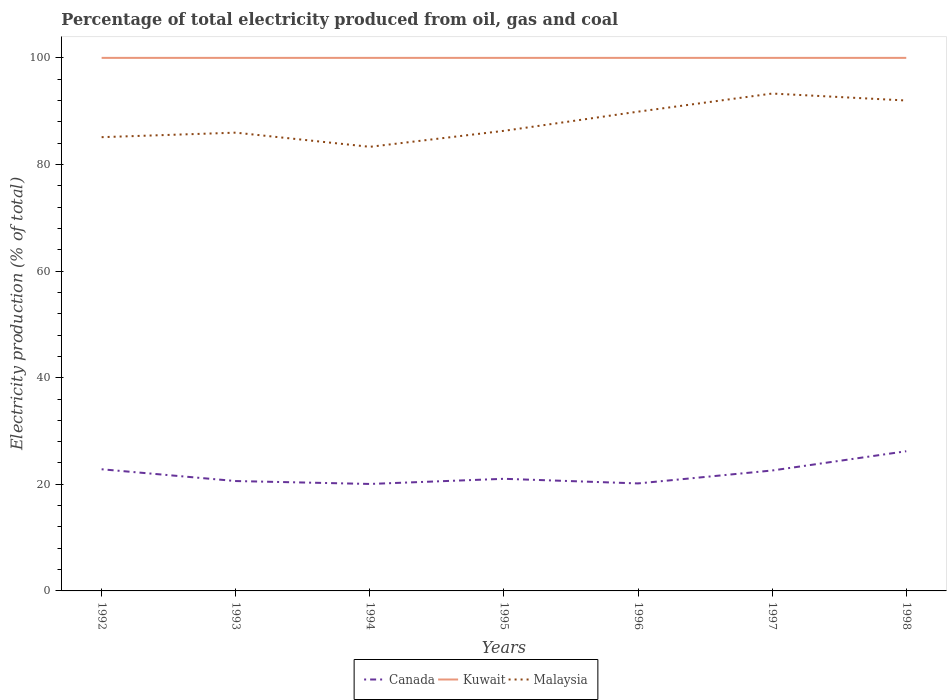How many different coloured lines are there?
Provide a short and direct response. 3. Is the number of lines equal to the number of legend labels?
Your answer should be very brief. Yes. Across all years, what is the maximum electricity production in in Canada?
Make the answer very short. 20.07. What is the total electricity production in in Malaysia in the graph?
Give a very brief answer. -3.6. What is the difference between the highest and the second highest electricity production in in Malaysia?
Offer a terse response. 9.99. What is the difference between the highest and the lowest electricity production in in Malaysia?
Provide a short and direct response. 3. Is the electricity production in in Malaysia strictly greater than the electricity production in in Canada over the years?
Offer a terse response. No. What is the difference between two consecutive major ticks on the Y-axis?
Provide a short and direct response. 20. Does the graph contain grids?
Provide a succinct answer. No. Where does the legend appear in the graph?
Provide a succinct answer. Bottom center. How many legend labels are there?
Your answer should be compact. 3. How are the legend labels stacked?
Your answer should be very brief. Horizontal. What is the title of the graph?
Offer a very short reply. Percentage of total electricity produced from oil, gas and coal. Does "Sri Lanka" appear as one of the legend labels in the graph?
Keep it short and to the point. No. What is the label or title of the Y-axis?
Keep it short and to the point. Electricity production (% of total). What is the Electricity production (% of total) in Canada in 1992?
Your answer should be very brief. 22.82. What is the Electricity production (% of total) in Malaysia in 1992?
Ensure brevity in your answer.  85.13. What is the Electricity production (% of total) of Canada in 1993?
Offer a terse response. 20.61. What is the Electricity production (% of total) in Malaysia in 1993?
Give a very brief answer. 85.97. What is the Electricity production (% of total) of Canada in 1994?
Your response must be concise. 20.07. What is the Electricity production (% of total) of Malaysia in 1994?
Give a very brief answer. 83.31. What is the Electricity production (% of total) of Canada in 1995?
Your answer should be very brief. 21.03. What is the Electricity production (% of total) in Kuwait in 1995?
Your answer should be compact. 100. What is the Electricity production (% of total) in Malaysia in 1995?
Ensure brevity in your answer.  86.31. What is the Electricity production (% of total) in Canada in 1996?
Your answer should be very brief. 20.17. What is the Electricity production (% of total) of Malaysia in 1996?
Provide a succinct answer. 89.91. What is the Electricity production (% of total) of Canada in 1997?
Your answer should be very brief. 22.59. What is the Electricity production (% of total) in Kuwait in 1997?
Offer a very short reply. 100. What is the Electricity production (% of total) in Malaysia in 1997?
Your answer should be very brief. 93.31. What is the Electricity production (% of total) in Canada in 1998?
Ensure brevity in your answer.  26.21. What is the Electricity production (% of total) of Kuwait in 1998?
Give a very brief answer. 100. What is the Electricity production (% of total) of Malaysia in 1998?
Offer a terse response. 92. Across all years, what is the maximum Electricity production (% of total) in Canada?
Provide a short and direct response. 26.21. Across all years, what is the maximum Electricity production (% of total) in Malaysia?
Provide a succinct answer. 93.31. Across all years, what is the minimum Electricity production (% of total) of Canada?
Ensure brevity in your answer.  20.07. Across all years, what is the minimum Electricity production (% of total) of Malaysia?
Provide a succinct answer. 83.31. What is the total Electricity production (% of total) of Canada in the graph?
Offer a terse response. 153.5. What is the total Electricity production (% of total) in Kuwait in the graph?
Give a very brief answer. 700. What is the total Electricity production (% of total) in Malaysia in the graph?
Your answer should be very brief. 615.95. What is the difference between the Electricity production (% of total) of Canada in 1992 and that in 1993?
Provide a short and direct response. 2.21. What is the difference between the Electricity production (% of total) of Malaysia in 1992 and that in 1993?
Give a very brief answer. -0.85. What is the difference between the Electricity production (% of total) in Canada in 1992 and that in 1994?
Your response must be concise. 2.76. What is the difference between the Electricity production (% of total) of Malaysia in 1992 and that in 1994?
Make the answer very short. 1.81. What is the difference between the Electricity production (% of total) in Canada in 1992 and that in 1995?
Your response must be concise. 1.79. What is the difference between the Electricity production (% of total) in Malaysia in 1992 and that in 1995?
Keep it short and to the point. -1.19. What is the difference between the Electricity production (% of total) in Canada in 1992 and that in 1996?
Offer a very short reply. 2.66. What is the difference between the Electricity production (% of total) of Kuwait in 1992 and that in 1996?
Your response must be concise. 0. What is the difference between the Electricity production (% of total) in Malaysia in 1992 and that in 1996?
Your answer should be compact. -4.79. What is the difference between the Electricity production (% of total) of Canada in 1992 and that in 1997?
Offer a very short reply. 0.23. What is the difference between the Electricity production (% of total) of Malaysia in 1992 and that in 1997?
Make the answer very short. -8.18. What is the difference between the Electricity production (% of total) of Canada in 1992 and that in 1998?
Your response must be concise. -3.38. What is the difference between the Electricity production (% of total) in Malaysia in 1992 and that in 1998?
Offer a very short reply. -6.88. What is the difference between the Electricity production (% of total) of Canada in 1993 and that in 1994?
Keep it short and to the point. 0.55. What is the difference between the Electricity production (% of total) of Malaysia in 1993 and that in 1994?
Your answer should be very brief. 2.66. What is the difference between the Electricity production (% of total) in Canada in 1993 and that in 1995?
Your answer should be very brief. -0.42. What is the difference between the Electricity production (% of total) of Kuwait in 1993 and that in 1995?
Give a very brief answer. 0. What is the difference between the Electricity production (% of total) of Malaysia in 1993 and that in 1995?
Provide a succinct answer. -0.34. What is the difference between the Electricity production (% of total) of Canada in 1993 and that in 1996?
Your response must be concise. 0.45. What is the difference between the Electricity production (% of total) in Malaysia in 1993 and that in 1996?
Ensure brevity in your answer.  -3.94. What is the difference between the Electricity production (% of total) in Canada in 1993 and that in 1997?
Keep it short and to the point. -1.98. What is the difference between the Electricity production (% of total) in Kuwait in 1993 and that in 1997?
Provide a succinct answer. 0. What is the difference between the Electricity production (% of total) in Malaysia in 1993 and that in 1997?
Offer a very short reply. -7.34. What is the difference between the Electricity production (% of total) in Canada in 1993 and that in 1998?
Offer a terse response. -5.59. What is the difference between the Electricity production (% of total) of Malaysia in 1993 and that in 1998?
Ensure brevity in your answer.  -6.03. What is the difference between the Electricity production (% of total) in Canada in 1994 and that in 1995?
Your response must be concise. -0.97. What is the difference between the Electricity production (% of total) of Malaysia in 1994 and that in 1995?
Provide a succinct answer. -3. What is the difference between the Electricity production (% of total) of Canada in 1994 and that in 1996?
Give a very brief answer. -0.1. What is the difference between the Electricity production (% of total) of Kuwait in 1994 and that in 1996?
Your answer should be very brief. 0. What is the difference between the Electricity production (% of total) in Malaysia in 1994 and that in 1996?
Offer a terse response. -6.6. What is the difference between the Electricity production (% of total) of Canada in 1994 and that in 1997?
Give a very brief answer. -2.53. What is the difference between the Electricity production (% of total) in Malaysia in 1994 and that in 1997?
Give a very brief answer. -9.99. What is the difference between the Electricity production (% of total) in Canada in 1994 and that in 1998?
Keep it short and to the point. -6.14. What is the difference between the Electricity production (% of total) of Kuwait in 1994 and that in 1998?
Give a very brief answer. 0. What is the difference between the Electricity production (% of total) of Malaysia in 1994 and that in 1998?
Provide a short and direct response. -8.69. What is the difference between the Electricity production (% of total) of Canada in 1995 and that in 1996?
Give a very brief answer. 0.87. What is the difference between the Electricity production (% of total) of Kuwait in 1995 and that in 1996?
Provide a short and direct response. 0. What is the difference between the Electricity production (% of total) of Malaysia in 1995 and that in 1996?
Give a very brief answer. -3.6. What is the difference between the Electricity production (% of total) in Canada in 1995 and that in 1997?
Make the answer very short. -1.56. What is the difference between the Electricity production (% of total) in Malaysia in 1995 and that in 1997?
Give a very brief answer. -7. What is the difference between the Electricity production (% of total) of Canada in 1995 and that in 1998?
Offer a very short reply. -5.17. What is the difference between the Electricity production (% of total) of Malaysia in 1995 and that in 1998?
Make the answer very short. -5.69. What is the difference between the Electricity production (% of total) in Canada in 1996 and that in 1997?
Offer a very short reply. -2.43. What is the difference between the Electricity production (% of total) in Kuwait in 1996 and that in 1997?
Offer a very short reply. 0. What is the difference between the Electricity production (% of total) in Malaysia in 1996 and that in 1997?
Give a very brief answer. -3.4. What is the difference between the Electricity production (% of total) in Canada in 1996 and that in 1998?
Your answer should be very brief. -6.04. What is the difference between the Electricity production (% of total) in Malaysia in 1996 and that in 1998?
Your answer should be very brief. -2.09. What is the difference between the Electricity production (% of total) of Canada in 1997 and that in 1998?
Your answer should be compact. -3.61. What is the difference between the Electricity production (% of total) of Malaysia in 1997 and that in 1998?
Provide a succinct answer. 1.31. What is the difference between the Electricity production (% of total) of Canada in 1992 and the Electricity production (% of total) of Kuwait in 1993?
Offer a very short reply. -77.18. What is the difference between the Electricity production (% of total) in Canada in 1992 and the Electricity production (% of total) in Malaysia in 1993?
Ensure brevity in your answer.  -63.15. What is the difference between the Electricity production (% of total) of Kuwait in 1992 and the Electricity production (% of total) of Malaysia in 1993?
Your answer should be very brief. 14.03. What is the difference between the Electricity production (% of total) in Canada in 1992 and the Electricity production (% of total) in Kuwait in 1994?
Your answer should be very brief. -77.18. What is the difference between the Electricity production (% of total) of Canada in 1992 and the Electricity production (% of total) of Malaysia in 1994?
Your answer should be compact. -60.49. What is the difference between the Electricity production (% of total) of Kuwait in 1992 and the Electricity production (% of total) of Malaysia in 1994?
Your answer should be compact. 16.69. What is the difference between the Electricity production (% of total) in Canada in 1992 and the Electricity production (% of total) in Kuwait in 1995?
Provide a short and direct response. -77.18. What is the difference between the Electricity production (% of total) in Canada in 1992 and the Electricity production (% of total) in Malaysia in 1995?
Provide a short and direct response. -63.49. What is the difference between the Electricity production (% of total) in Kuwait in 1992 and the Electricity production (% of total) in Malaysia in 1995?
Your answer should be compact. 13.69. What is the difference between the Electricity production (% of total) of Canada in 1992 and the Electricity production (% of total) of Kuwait in 1996?
Your answer should be compact. -77.18. What is the difference between the Electricity production (% of total) of Canada in 1992 and the Electricity production (% of total) of Malaysia in 1996?
Your answer should be very brief. -67.09. What is the difference between the Electricity production (% of total) of Kuwait in 1992 and the Electricity production (% of total) of Malaysia in 1996?
Offer a very short reply. 10.09. What is the difference between the Electricity production (% of total) of Canada in 1992 and the Electricity production (% of total) of Kuwait in 1997?
Your response must be concise. -77.18. What is the difference between the Electricity production (% of total) in Canada in 1992 and the Electricity production (% of total) in Malaysia in 1997?
Your response must be concise. -70.49. What is the difference between the Electricity production (% of total) in Kuwait in 1992 and the Electricity production (% of total) in Malaysia in 1997?
Keep it short and to the point. 6.69. What is the difference between the Electricity production (% of total) of Canada in 1992 and the Electricity production (% of total) of Kuwait in 1998?
Ensure brevity in your answer.  -77.18. What is the difference between the Electricity production (% of total) of Canada in 1992 and the Electricity production (% of total) of Malaysia in 1998?
Make the answer very short. -69.18. What is the difference between the Electricity production (% of total) in Kuwait in 1992 and the Electricity production (% of total) in Malaysia in 1998?
Keep it short and to the point. 8. What is the difference between the Electricity production (% of total) in Canada in 1993 and the Electricity production (% of total) in Kuwait in 1994?
Offer a terse response. -79.39. What is the difference between the Electricity production (% of total) in Canada in 1993 and the Electricity production (% of total) in Malaysia in 1994?
Provide a short and direct response. -62.7. What is the difference between the Electricity production (% of total) in Kuwait in 1993 and the Electricity production (% of total) in Malaysia in 1994?
Provide a succinct answer. 16.69. What is the difference between the Electricity production (% of total) in Canada in 1993 and the Electricity production (% of total) in Kuwait in 1995?
Ensure brevity in your answer.  -79.39. What is the difference between the Electricity production (% of total) of Canada in 1993 and the Electricity production (% of total) of Malaysia in 1995?
Ensure brevity in your answer.  -65.7. What is the difference between the Electricity production (% of total) of Kuwait in 1993 and the Electricity production (% of total) of Malaysia in 1995?
Provide a succinct answer. 13.69. What is the difference between the Electricity production (% of total) of Canada in 1993 and the Electricity production (% of total) of Kuwait in 1996?
Make the answer very short. -79.39. What is the difference between the Electricity production (% of total) in Canada in 1993 and the Electricity production (% of total) in Malaysia in 1996?
Ensure brevity in your answer.  -69.3. What is the difference between the Electricity production (% of total) of Kuwait in 1993 and the Electricity production (% of total) of Malaysia in 1996?
Your response must be concise. 10.09. What is the difference between the Electricity production (% of total) of Canada in 1993 and the Electricity production (% of total) of Kuwait in 1997?
Ensure brevity in your answer.  -79.39. What is the difference between the Electricity production (% of total) in Canada in 1993 and the Electricity production (% of total) in Malaysia in 1997?
Your answer should be very brief. -72.69. What is the difference between the Electricity production (% of total) in Kuwait in 1993 and the Electricity production (% of total) in Malaysia in 1997?
Offer a terse response. 6.69. What is the difference between the Electricity production (% of total) in Canada in 1993 and the Electricity production (% of total) in Kuwait in 1998?
Make the answer very short. -79.39. What is the difference between the Electricity production (% of total) in Canada in 1993 and the Electricity production (% of total) in Malaysia in 1998?
Make the answer very short. -71.39. What is the difference between the Electricity production (% of total) of Kuwait in 1993 and the Electricity production (% of total) of Malaysia in 1998?
Give a very brief answer. 8. What is the difference between the Electricity production (% of total) in Canada in 1994 and the Electricity production (% of total) in Kuwait in 1995?
Ensure brevity in your answer.  -79.93. What is the difference between the Electricity production (% of total) in Canada in 1994 and the Electricity production (% of total) in Malaysia in 1995?
Offer a terse response. -66.25. What is the difference between the Electricity production (% of total) of Kuwait in 1994 and the Electricity production (% of total) of Malaysia in 1995?
Provide a succinct answer. 13.69. What is the difference between the Electricity production (% of total) of Canada in 1994 and the Electricity production (% of total) of Kuwait in 1996?
Offer a terse response. -79.93. What is the difference between the Electricity production (% of total) in Canada in 1994 and the Electricity production (% of total) in Malaysia in 1996?
Your answer should be compact. -69.85. What is the difference between the Electricity production (% of total) of Kuwait in 1994 and the Electricity production (% of total) of Malaysia in 1996?
Ensure brevity in your answer.  10.09. What is the difference between the Electricity production (% of total) of Canada in 1994 and the Electricity production (% of total) of Kuwait in 1997?
Offer a terse response. -79.93. What is the difference between the Electricity production (% of total) in Canada in 1994 and the Electricity production (% of total) in Malaysia in 1997?
Provide a short and direct response. -73.24. What is the difference between the Electricity production (% of total) of Kuwait in 1994 and the Electricity production (% of total) of Malaysia in 1997?
Give a very brief answer. 6.69. What is the difference between the Electricity production (% of total) of Canada in 1994 and the Electricity production (% of total) of Kuwait in 1998?
Offer a terse response. -79.93. What is the difference between the Electricity production (% of total) in Canada in 1994 and the Electricity production (% of total) in Malaysia in 1998?
Provide a succinct answer. -71.94. What is the difference between the Electricity production (% of total) in Kuwait in 1994 and the Electricity production (% of total) in Malaysia in 1998?
Your response must be concise. 8. What is the difference between the Electricity production (% of total) of Canada in 1995 and the Electricity production (% of total) of Kuwait in 1996?
Your answer should be compact. -78.97. What is the difference between the Electricity production (% of total) in Canada in 1995 and the Electricity production (% of total) in Malaysia in 1996?
Ensure brevity in your answer.  -68.88. What is the difference between the Electricity production (% of total) in Kuwait in 1995 and the Electricity production (% of total) in Malaysia in 1996?
Your answer should be very brief. 10.09. What is the difference between the Electricity production (% of total) of Canada in 1995 and the Electricity production (% of total) of Kuwait in 1997?
Offer a very short reply. -78.97. What is the difference between the Electricity production (% of total) in Canada in 1995 and the Electricity production (% of total) in Malaysia in 1997?
Keep it short and to the point. -72.28. What is the difference between the Electricity production (% of total) of Kuwait in 1995 and the Electricity production (% of total) of Malaysia in 1997?
Your response must be concise. 6.69. What is the difference between the Electricity production (% of total) in Canada in 1995 and the Electricity production (% of total) in Kuwait in 1998?
Your answer should be compact. -78.97. What is the difference between the Electricity production (% of total) in Canada in 1995 and the Electricity production (% of total) in Malaysia in 1998?
Make the answer very short. -70.97. What is the difference between the Electricity production (% of total) of Kuwait in 1995 and the Electricity production (% of total) of Malaysia in 1998?
Offer a very short reply. 8. What is the difference between the Electricity production (% of total) of Canada in 1996 and the Electricity production (% of total) of Kuwait in 1997?
Your answer should be very brief. -79.83. What is the difference between the Electricity production (% of total) of Canada in 1996 and the Electricity production (% of total) of Malaysia in 1997?
Your response must be concise. -73.14. What is the difference between the Electricity production (% of total) in Kuwait in 1996 and the Electricity production (% of total) in Malaysia in 1997?
Your answer should be very brief. 6.69. What is the difference between the Electricity production (% of total) in Canada in 1996 and the Electricity production (% of total) in Kuwait in 1998?
Your answer should be very brief. -79.83. What is the difference between the Electricity production (% of total) of Canada in 1996 and the Electricity production (% of total) of Malaysia in 1998?
Offer a terse response. -71.84. What is the difference between the Electricity production (% of total) of Kuwait in 1996 and the Electricity production (% of total) of Malaysia in 1998?
Offer a very short reply. 8. What is the difference between the Electricity production (% of total) of Canada in 1997 and the Electricity production (% of total) of Kuwait in 1998?
Keep it short and to the point. -77.41. What is the difference between the Electricity production (% of total) of Canada in 1997 and the Electricity production (% of total) of Malaysia in 1998?
Offer a terse response. -69.41. What is the difference between the Electricity production (% of total) of Kuwait in 1997 and the Electricity production (% of total) of Malaysia in 1998?
Your answer should be very brief. 8. What is the average Electricity production (% of total) of Canada per year?
Offer a terse response. 21.93. What is the average Electricity production (% of total) of Malaysia per year?
Your response must be concise. 87.99. In the year 1992, what is the difference between the Electricity production (% of total) in Canada and Electricity production (% of total) in Kuwait?
Your answer should be compact. -77.18. In the year 1992, what is the difference between the Electricity production (% of total) in Canada and Electricity production (% of total) in Malaysia?
Offer a terse response. -62.3. In the year 1992, what is the difference between the Electricity production (% of total) in Kuwait and Electricity production (% of total) in Malaysia?
Give a very brief answer. 14.87. In the year 1993, what is the difference between the Electricity production (% of total) in Canada and Electricity production (% of total) in Kuwait?
Ensure brevity in your answer.  -79.39. In the year 1993, what is the difference between the Electricity production (% of total) in Canada and Electricity production (% of total) in Malaysia?
Your answer should be very brief. -65.36. In the year 1993, what is the difference between the Electricity production (% of total) of Kuwait and Electricity production (% of total) of Malaysia?
Offer a very short reply. 14.03. In the year 1994, what is the difference between the Electricity production (% of total) of Canada and Electricity production (% of total) of Kuwait?
Give a very brief answer. -79.93. In the year 1994, what is the difference between the Electricity production (% of total) in Canada and Electricity production (% of total) in Malaysia?
Provide a succinct answer. -63.25. In the year 1994, what is the difference between the Electricity production (% of total) in Kuwait and Electricity production (% of total) in Malaysia?
Offer a terse response. 16.69. In the year 1995, what is the difference between the Electricity production (% of total) of Canada and Electricity production (% of total) of Kuwait?
Your answer should be very brief. -78.97. In the year 1995, what is the difference between the Electricity production (% of total) in Canada and Electricity production (% of total) in Malaysia?
Ensure brevity in your answer.  -65.28. In the year 1995, what is the difference between the Electricity production (% of total) in Kuwait and Electricity production (% of total) in Malaysia?
Give a very brief answer. 13.69. In the year 1996, what is the difference between the Electricity production (% of total) of Canada and Electricity production (% of total) of Kuwait?
Make the answer very short. -79.83. In the year 1996, what is the difference between the Electricity production (% of total) of Canada and Electricity production (% of total) of Malaysia?
Provide a succinct answer. -69.74. In the year 1996, what is the difference between the Electricity production (% of total) in Kuwait and Electricity production (% of total) in Malaysia?
Keep it short and to the point. 10.09. In the year 1997, what is the difference between the Electricity production (% of total) of Canada and Electricity production (% of total) of Kuwait?
Provide a short and direct response. -77.41. In the year 1997, what is the difference between the Electricity production (% of total) in Canada and Electricity production (% of total) in Malaysia?
Your answer should be compact. -70.72. In the year 1997, what is the difference between the Electricity production (% of total) of Kuwait and Electricity production (% of total) of Malaysia?
Ensure brevity in your answer.  6.69. In the year 1998, what is the difference between the Electricity production (% of total) in Canada and Electricity production (% of total) in Kuwait?
Provide a succinct answer. -73.79. In the year 1998, what is the difference between the Electricity production (% of total) of Canada and Electricity production (% of total) of Malaysia?
Make the answer very short. -65.8. In the year 1998, what is the difference between the Electricity production (% of total) of Kuwait and Electricity production (% of total) of Malaysia?
Your response must be concise. 8. What is the ratio of the Electricity production (% of total) of Canada in 1992 to that in 1993?
Keep it short and to the point. 1.11. What is the ratio of the Electricity production (% of total) in Canada in 1992 to that in 1994?
Offer a terse response. 1.14. What is the ratio of the Electricity production (% of total) in Kuwait in 1992 to that in 1994?
Provide a succinct answer. 1. What is the ratio of the Electricity production (% of total) of Malaysia in 1992 to that in 1994?
Your answer should be very brief. 1.02. What is the ratio of the Electricity production (% of total) in Canada in 1992 to that in 1995?
Provide a short and direct response. 1.09. What is the ratio of the Electricity production (% of total) in Malaysia in 1992 to that in 1995?
Keep it short and to the point. 0.99. What is the ratio of the Electricity production (% of total) of Canada in 1992 to that in 1996?
Give a very brief answer. 1.13. What is the ratio of the Electricity production (% of total) of Kuwait in 1992 to that in 1996?
Make the answer very short. 1. What is the ratio of the Electricity production (% of total) in Malaysia in 1992 to that in 1996?
Ensure brevity in your answer.  0.95. What is the ratio of the Electricity production (% of total) of Canada in 1992 to that in 1997?
Offer a terse response. 1.01. What is the ratio of the Electricity production (% of total) of Kuwait in 1992 to that in 1997?
Provide a short and direct response. 1. What is the ratio of the Electricity production (% of total) of Malaysia in 1992 to that in 1997?
Keep it short and to the point. 0.91. What is the ratio of the Electricity production (% of total) in Canada in 1992 to that in 1998?
Keep it short and to the point. 0.87. What is the ratio of the Electricity production (% of total) of Kuwait in 1992 to that in 1998?
Give a very brief answer. 1. What is the ratio of the Electricity production (% of total) in Malaysia in 1992 to that in 1998?
Provide a short and direct response. 0.93. What is the ratio of the Electricity production (% of total) in Canada in 1993 to that in 1994?
Ensure brevity in your answer.  1.03. What is the ratio of the Electricity production (% of total) in Kuwait in 1993 to that in 1994?
Provide a succinct answer. 1. What is the ratio of the Electricity production (% of total) in Malaysia in 1993 to that in 1994?
Your answer should be very brief. 1.03. What is the ratio of the Electricity production (% of total) in Canada in 1993 to that in 1995?
Make the answer very short. 0.98. What is the ratio of the Electricity production (% of total) in Kuwait in 1993 to that in 1995?
Offer a very short reply. 1. What is the ratio of the Electricity production (% of total) in Malaysia in 1993 to that in 1995?
Provide a succinct answer. 1. What is the ratio of the Electricity production (% of total) of Canada in 1993 to that in 1996?
Offer a very short reply. 1.02. What is the ratio of the Electricity production (% of total) in Kuwait in 1993 to that in 1996?
Your answer should be compact. 1. What is the ratio of the Electricity production (% of total) in Malaysia in 1993 to that in 1996?
Give a very brief answer. 0.96. What is the ratio of the Electricity production (% of total) in Canada in 1993 to that in 1997?
Provide a short and direct response. 0.91. What is the ratio of the Electricity production (% of total) in Malaysia in 1993 to that in 1997?
Ensure brevity in your answer.  0.92. What is the ratio of the Electricity production (% of total) in Canada in 1993 to that in 1998?
Provide a succinct answer. 0.79. What is the ratio of the Electricity production (% of total) of Malaysia in 1993 to that in 1998?
Your answer should be very brief. 0.93. What is the ratio of the Electricity production (% of total) in Canada in 1994 to that in 1995?
Keep it short and to the point. 0.95. What is the ratio of the Electricity production (% of total) of Malaysia in 1994 to that in 1995?
Keep it short and to the point. 0.97. What is the ratio of the Electricity production (% of total) of Malaysia in 1994 to that in 1996?
Ensure brevity in your answer.  0.93. What is the ratio of the Electricity production (% of total) of Canada in 1994 to that in 1997?
Your answer should be compact. 0.89. What is the ratio of the Electricity production (% of total) in Kuwait in 1994 to that in 1997?
Provide a short and direct response. 1. What is the ratio of the Electricity production (% of total) in Malaysia in 1994 to that in 1997?
Offer a terse response. 0.89. What is the ratio of the Electricity production (% of total) in Canada in 1994 to that in 1998?
Ensure brevity in your answer.  0.77. What is the ratio of the Electricity production (% of total) of Malaysia in 1994 to that in 1998?
Provide a short and direct response. 0.91. What is the ratio of the Electricity production (% of total) in Canada in 1995 to that in 1996?
Make the answer very short. 1.04. What is the ratio of the Electricity production (% of total) in Kuwait in 1995 to that in 1996?
Give a very brief answer. 1. What is the ratio of the Electricity production (% of total) in Malaysia in 1995 to that in 1996?
Your response must be concise. 0.96. What is the ratio of the Electricity production (% of total) of Canada in 1995 to that in 1997?
Make the answer very short. 0.93. What is the ratio of the Electricity production (% of total) of Kuwait in 1995 to that in 1997?
Keep it short and to the point. 1. What is the ratio of the Electricity production (% of total) in Malaysia in 1995 to that in 1997?
Your answer should be compact. 0.93. What is the ratio of the Electricity production (% of total) in Canada in 1995 to that in 1998?
Give a very brief answer. 0.8. What is the ratio of the Electricity production (% of total) of Malaysia in 1995 to that in 1998?
Offer a terse response. 0.94. What is the ratio of the Electricity production (% of total) in Canada in 1996 to that in 1997?
Make the answer very short. 0.89. What is the ratio of the Electricity production (% of total) in Kuwait in 1996 to that in 1997?
Make the answer very short. 1. What is the ratio of the Electricity production (% of total) in Malaysia in 1996 to that in 1997?
Ensure brevity in your answer.  0.96. What is the ratio of the Electricity production (% of total) of Canada in 1996 to that in 1998?
Ensure brevity in your answer.  0.77. What is the ratio of the Electricity production (% of total) of Malaysia in 1996 to that in 1998?
Your answer should be compact. 0.98. What is the ratio of the Electricity production (% of total) of Canada in 1997 to that in 1998?
Keep it short and to the point. 0.86. What is the ratio of the Electricity production (% of total) of Malaysia in 1997 to that in 1998?
Make the answer very short. 1.01. What is the difference between the highest and the second highest Electricity production (% of total) of Canada?
Offer a very short reply. 3.38. What is the difference between the highest and the second highest Electricity production (% of total) of Kuwait?
Your answer should be compact. 0. What is the difference between the highest and the second highest Electricity production (% of total) of Malaysia?
Ensure brevity in your answer.  1.31. What is the difference between the highest and the lowest Electricity production (% of total) in Canada?
Keep it short and to the point. 6.14. What is the difference between the highest and the lowest Electricity production (% of total) of Malaysia?
Ensure brevity in your answer.  9.99. 